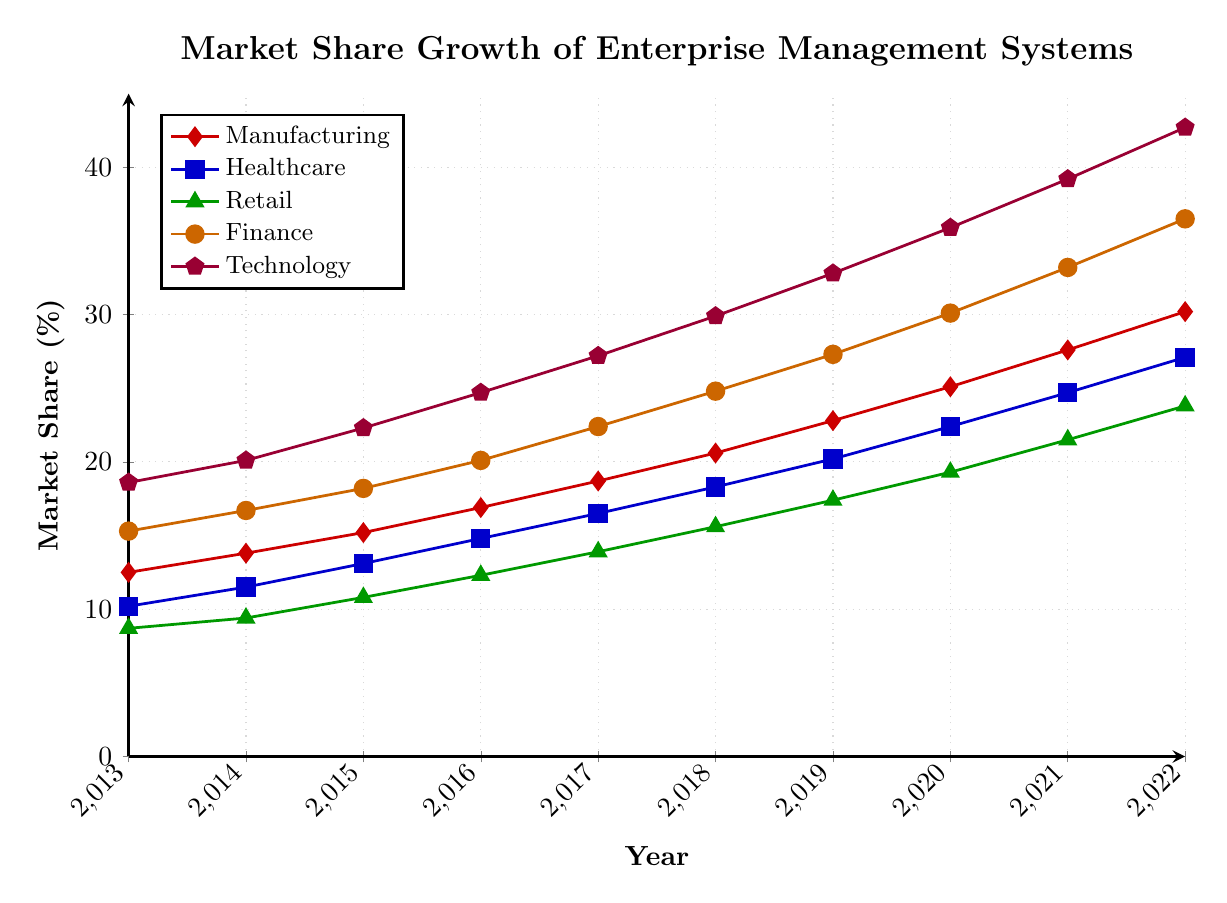What's the market share for Healthcare in 2020? Locate the blue line (Healthcare) in 2020 and read the value, which is 22.4%.
Answer: 22.4% Which sector had the highest market share in 2015? Check the values for each sector in 2015. Technology has the highest value at 22.3%.
Answer: Technology How much did the market share for Retail increase from 2013 to 2022? Subtract the value of Retail in 2013 (8.7%) from 2022 (23.8%). \(23.8 - 8.7 = 15.1\)
Answer: 15.1% Which sector shows the most consistent growth over the decade? Check the trendlines for each sector. All sectors show consistent growth, but Technology has the steepest and most consistent upward trajectory.
Answer: Technology What is the difference in market share between Finance and Manufacturing in 2022? Subtract the value of Manufacturing (30.2%) from Finance (36.5%). \(36.5 - 30.2 = 6.3\)
Answer: 6.3% By how much did the market share for Manufacturing grow between 2016 and 2017? Subtract the value of Manufacturing in 2016 (16.9%) from 2017 (18.7%). \(18.7 - 16.9 = 1.8\)
Answer: 1.8% In which year did the Technology sector surpass 30% market share? Locate the purple line (Technology) and find the first year it's above 30%. This occurs in 2019.
Answer: 2019 Which sector had the smallest increase in market share from 2013 to 2014? Calculate the increase for each sector by subtracting 2013 values from 2014. Retail increased by \(9.4 - 8.7 = 0.7\) which is the smallest increase.
Answer: Retail What is the average market share for Healthcare over the decade? Sum the Healthcare values from 2013 to 2022 and divide by 10. \((10.2 + 11.5 + 13.1 + 14.8 + 16.5 + 18.3 + 20.2 + 22.4 + 24.7 + 27.1) / 10 = 17.88\)
Answer: 17.88% Compare the growth trends of Finance and Technology between 2015 and 2020. Which one had a steeper increase? Calculate the growth for each sector: Finance increased from 18.2% to 30.1% \(30.1 - 18.2 = 11.9\), Technology increased from 22.3% to 35.9% \(35.9 - 22.3 = 13.6\). Technology had a steeper increase.
Answer: Technology 